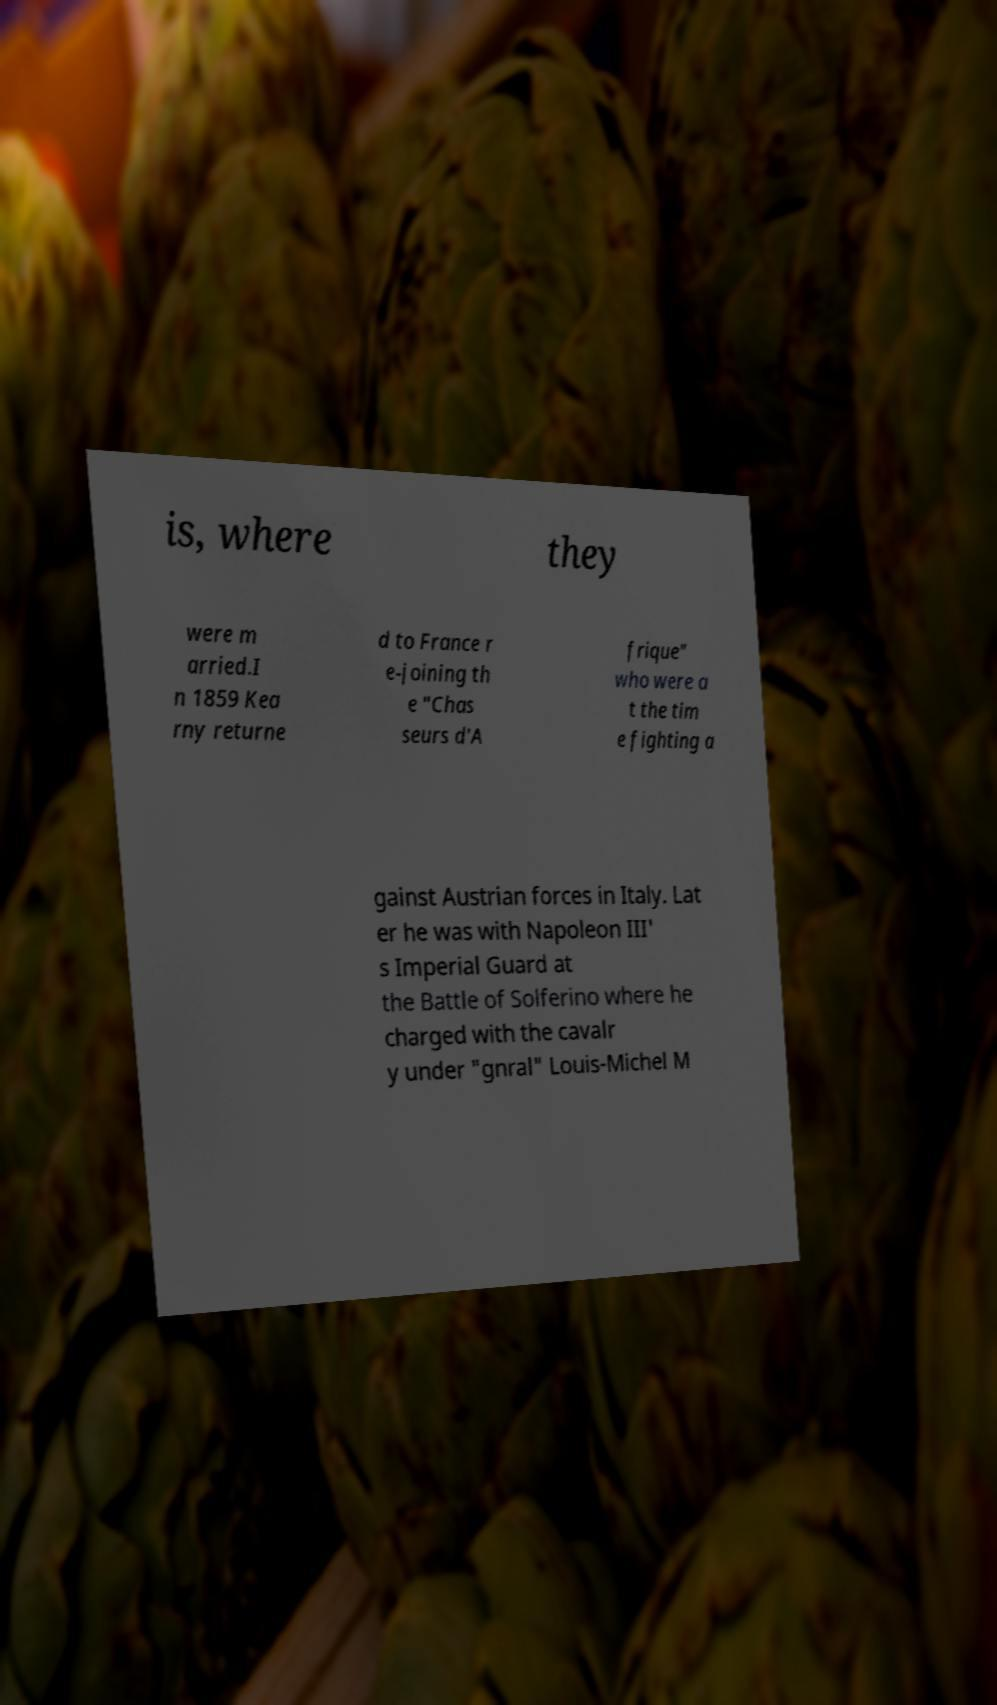Can you accurately transcribe the text from the provided image for me? is, where they were m arried.I n 1859 Kea rny returne d to France r e-joining th e "Chas seurs d'A frique" who were a t the tim e fighting a gainst Austrian forces in Italy. Lat er he was with Napoleon III' s Imperial Guard at the Battle of Solferino where he charged with the cavalr y under "gnral" Louis-Michel M 